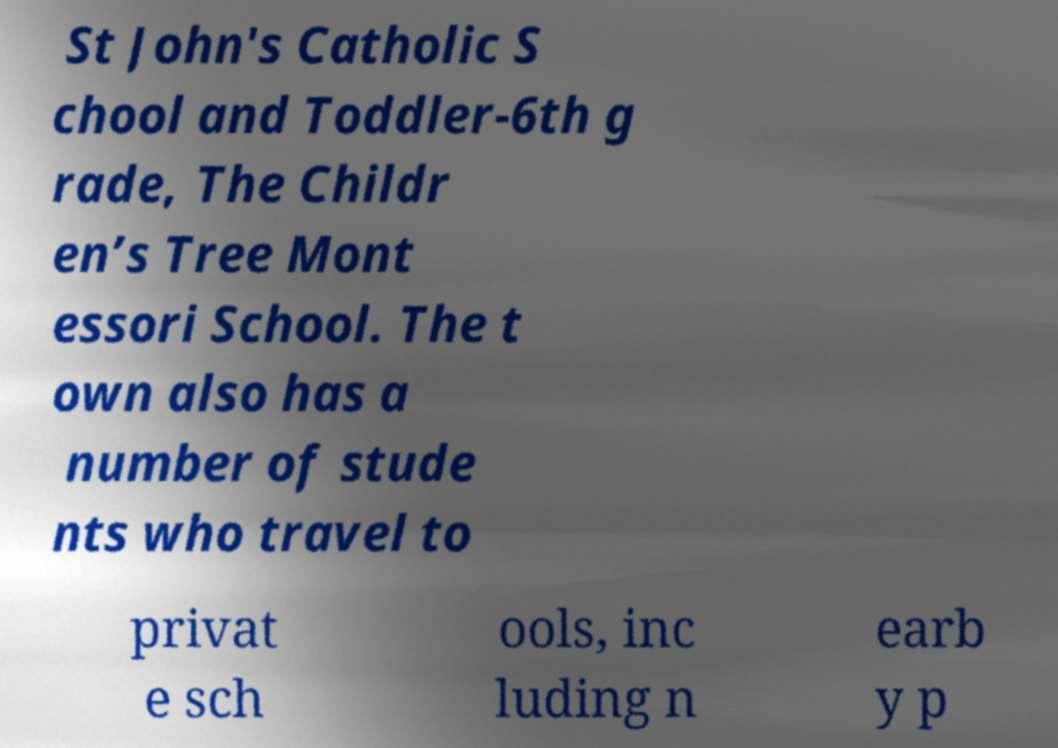What messages or text are displayed in this image? I need them in a readable, typed format. St John's Catholic S chool and Toddler-6th g rade, The Childr en’s Tree Mont essori School. The t own also has a number of stude nts who travel to privat e sch ools, inc luding n earb y p 